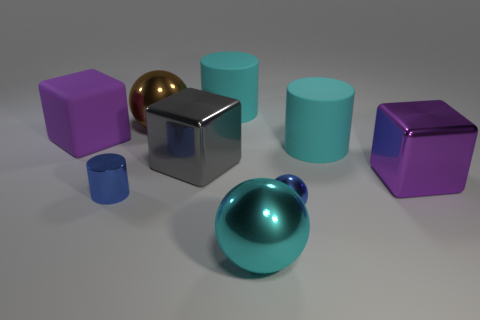Subtract all red cylinders. Subtract all gray spheres. How many cylinders are left? 3 Subtract all gray cylinders. How many gray blocks are left? 1 Add 1 tiny things. How many blues exist? 0 Subtract all cyan things. Subtract all blue objects. How many objects are left? 4 Add 3 large cyan metallic spheres. How many large cyan metallic spheres are left? 4 Add 5 blue rubber blocks. How many blue rubber blocks exist? 5 Add 1 purple rubber things. How many objects exist? 10 Subtract all blue cylinders. How many cylinders are left? 2 Subtract all gray cubes. How many cubes are left? 2 Subtract 0 purple balls. How many objects are left? 9 